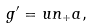<formula> <loc_0><loc_0><loc_500><loc_500>g ^ { \prime } = u n _ { + } a ,</formula> 